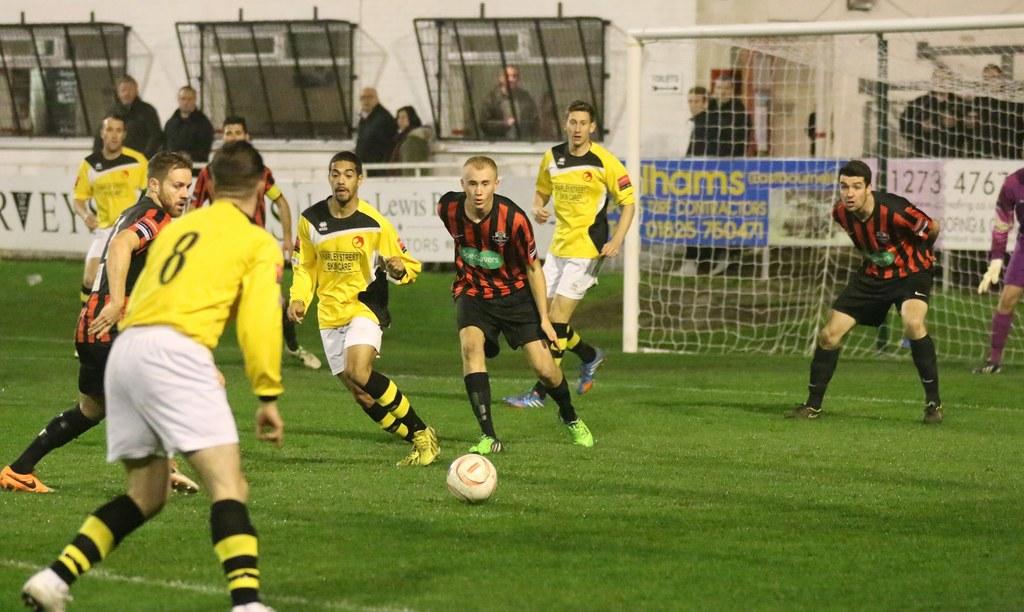What number is on the back of the players jersey?
Your answer should be very brief. 8. What are the numbers on the far right in the background?
Offer a terse response. 1273 476. 